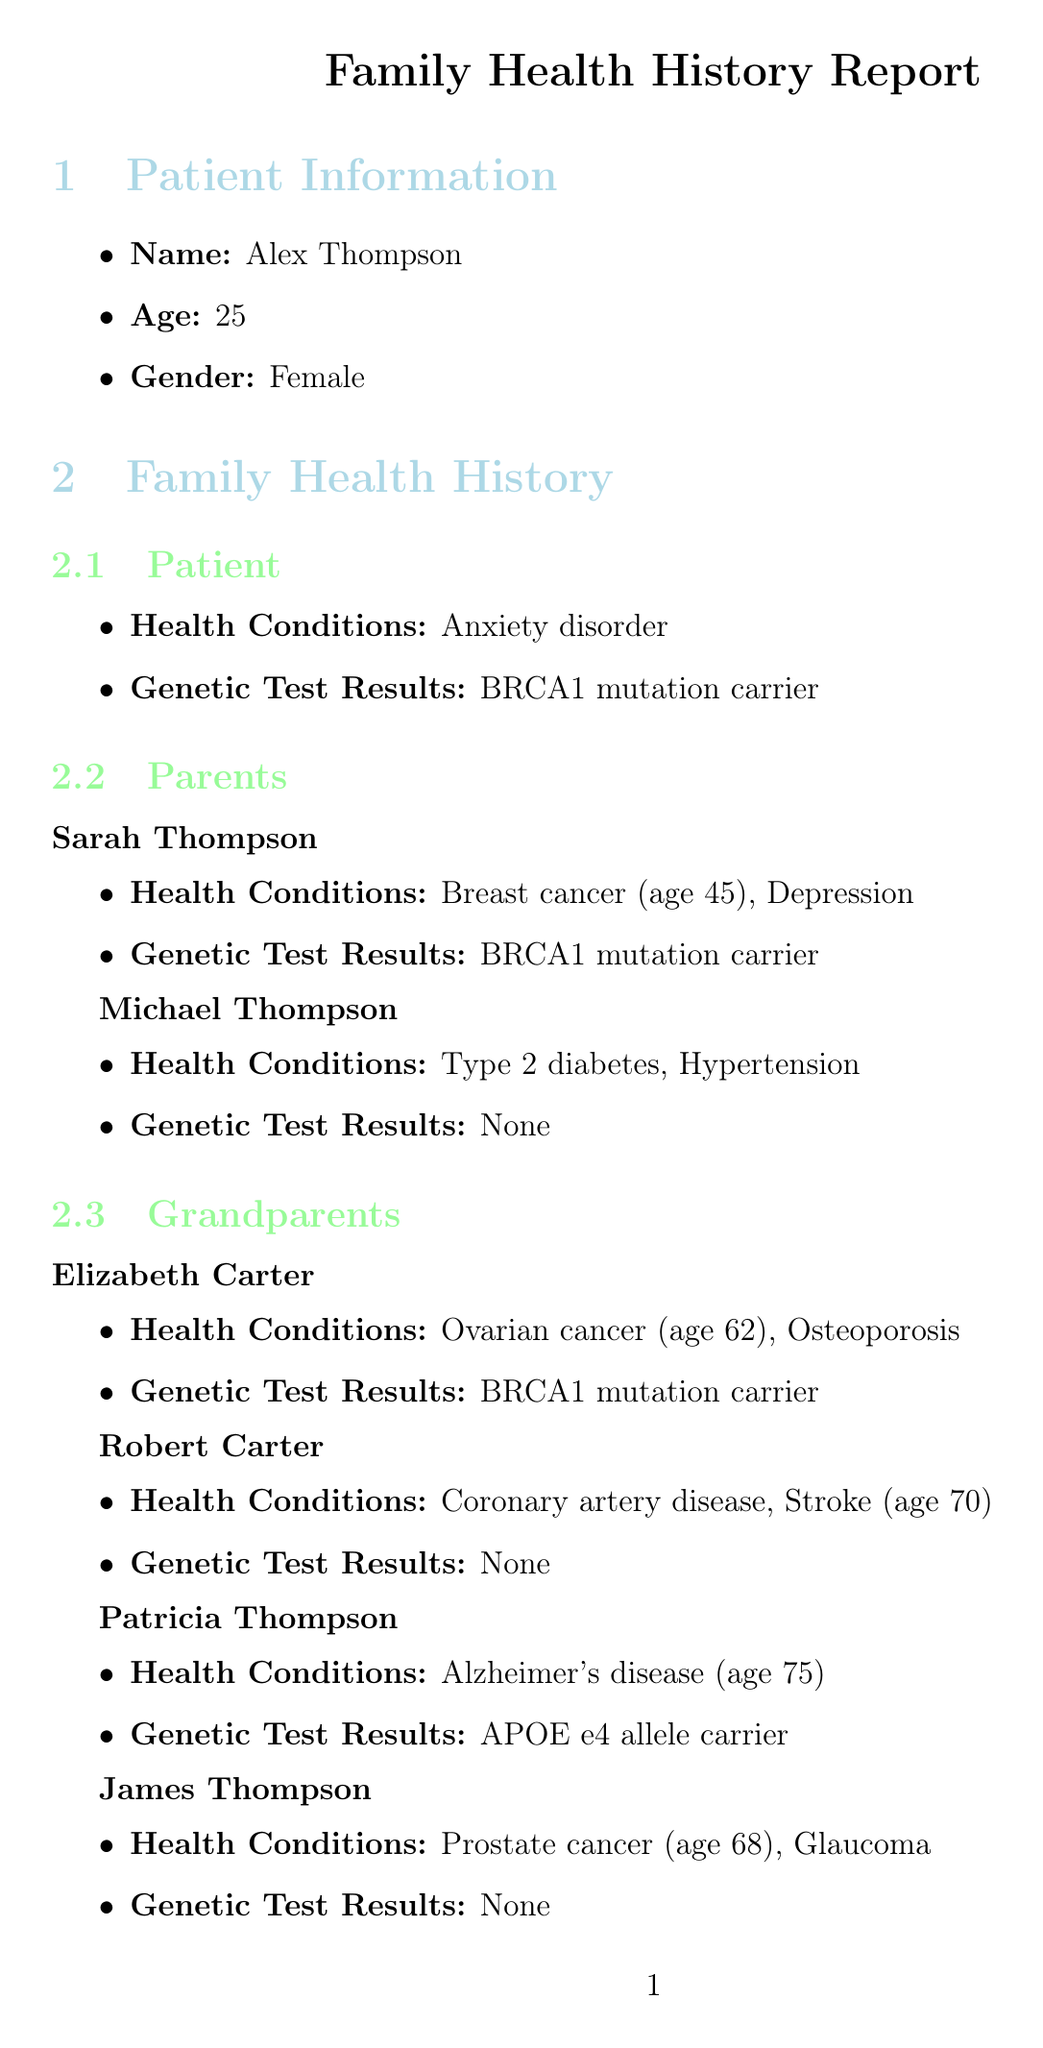What are the health conditions listed for Alex Thompson? The document states that Alex Thompson has the health condition of anxiety disorder.
Answer: Anxiety disorder What genetic mutation is Alex Thompson a carrier of? The document indicates that Alex Thompson is a carrier of the BRCA1 mutation.
Answer: BRCA1 mutation At what age did Sarah Thompson develop breast cancer? According to the document, Sarah Thompson developed breast cancer at the age of 45.
Answer: 45 Which family member has the risk management option of cognitive screening? The document states that cognitive screening is a risk management option for Patricia Thompson, who is affected by late-onset Alzheimer's disease.
Answer: Patricia Thompson What is the recommended frequency for a mammogram for Alex Thompson? The document suggests that the frequency for a mammogram for Alex Thompson is annual.
Answer: Annual How many generations are listed in the family health history? The document comprises three generations: Patient, Parents, and Grandparents.
Answer: Three Which inherited condition affects members through the BRCA1 gene? The document notes that the hereditary breast and ovarian cancer syndrome (HBOC) is associated with the BRCA1 gene.
Answer: HBOC What lifestyle factor is associated with lung cancer risk in the family? The document mentions smoking as a lifestyle factor associated with lung cancer risk among Michael Thompson and James Thompson.
Answer: Smoking What support is mentioned in the genetic counseling notes? The document indicates that resources for support groups and additional information on HBOC are provided in the genetic counseling notes.
Answer: Support groups and additional information on HBOC 